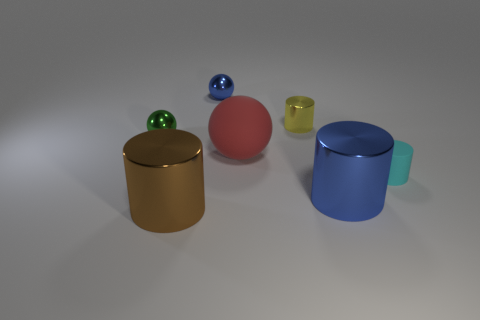Add 2 tiny purple shiny cubes. How many objects exist? 9 Subtract all spheres. How many objects are left? 4 Add 7 red rubber spheres. How many red rubber spheres are left? 8 Add 6 small yellow metallic objects. How many small yellow metallic objects exist? 7 Subtract 0 red blocks. How many objects are left? 7 Subtract all brown cylinders. Subtract all tiny cyan matte objects. How many objects are left? 5 